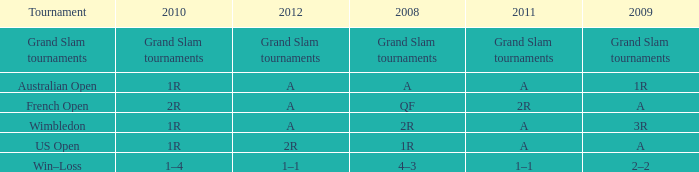Name the 2010 for tournament of us open 1R. 